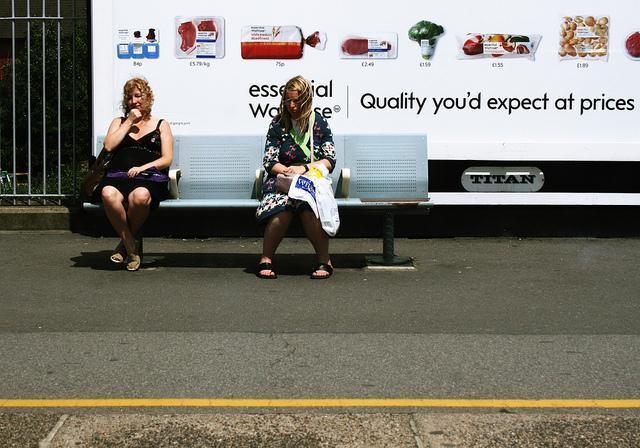How many benches are in the picture?
Give a very brief answer. 1. How many people are in the photo?
Give a very brief answer. 2. How many elephants are under a tree branch?
Give a very brief answer. 0. 